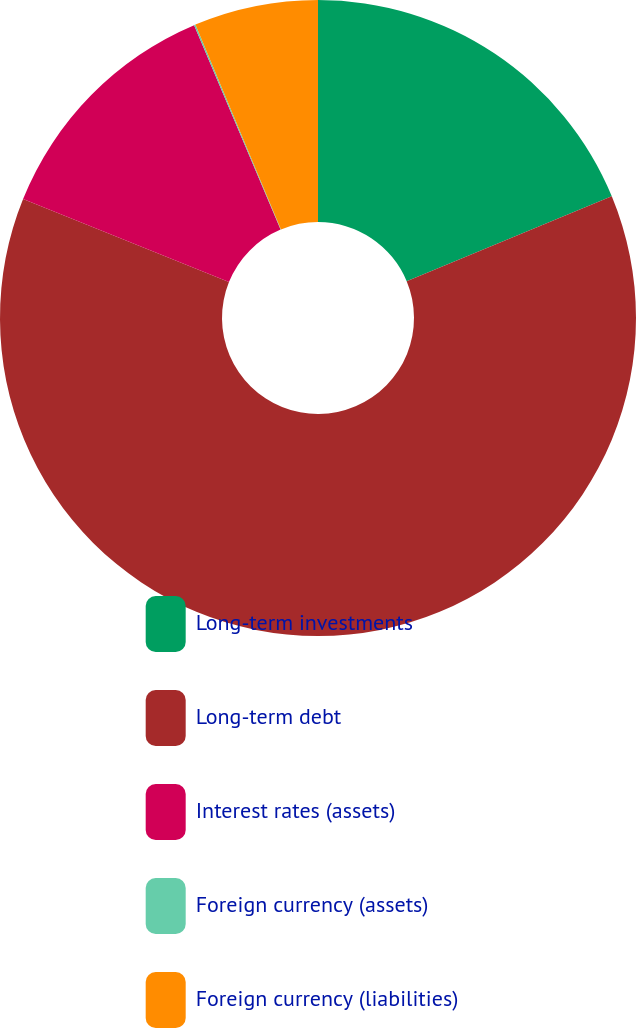<chart> <loc_0><loc_0><loc_500><loc_500><pie_chart><fcel>Long-term investments<fcel>Long-term debt<fcel>Interest rates (assets)<fcel>Foreign currency (assets)<fcel>Foreign currency (liabilities)<nl><fcel>18.75%<fcel>62.36%<fcel>12.53%<fcel>0.07%<fcel>6.3%<nl></chart> 